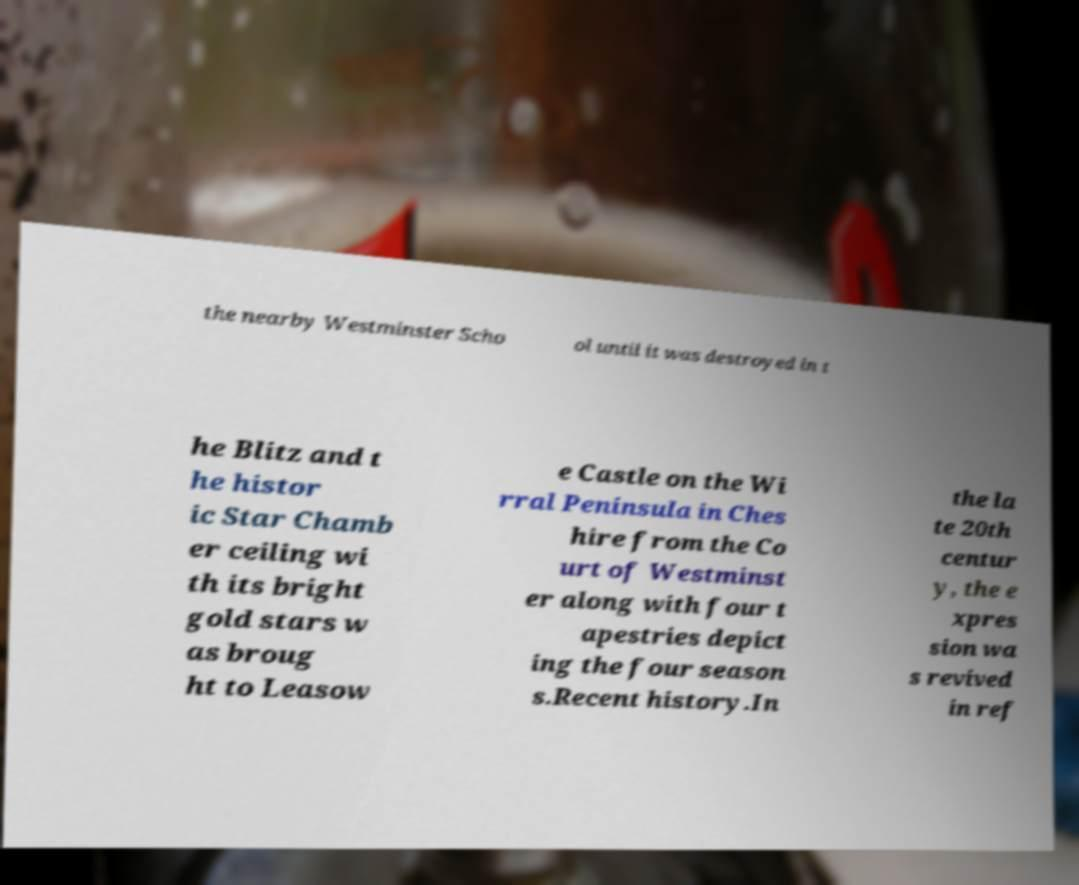For documentation purposes, I need the text within this image transcribed. Could you provide that? the nearby Westminster Scho ol until it was destroyed in t he Blitz and t he histor ic Star Chamb er ceiling wi th its bright gold stars w as broug ht to Leasow e Castle on the Wi rral Peninsula in Ches hire from the Co urt of Westminst er along with four t apestries depict ing the four season s.Recent history.In the la te 20th centur y, the e xpres sion wa s revived in ref 